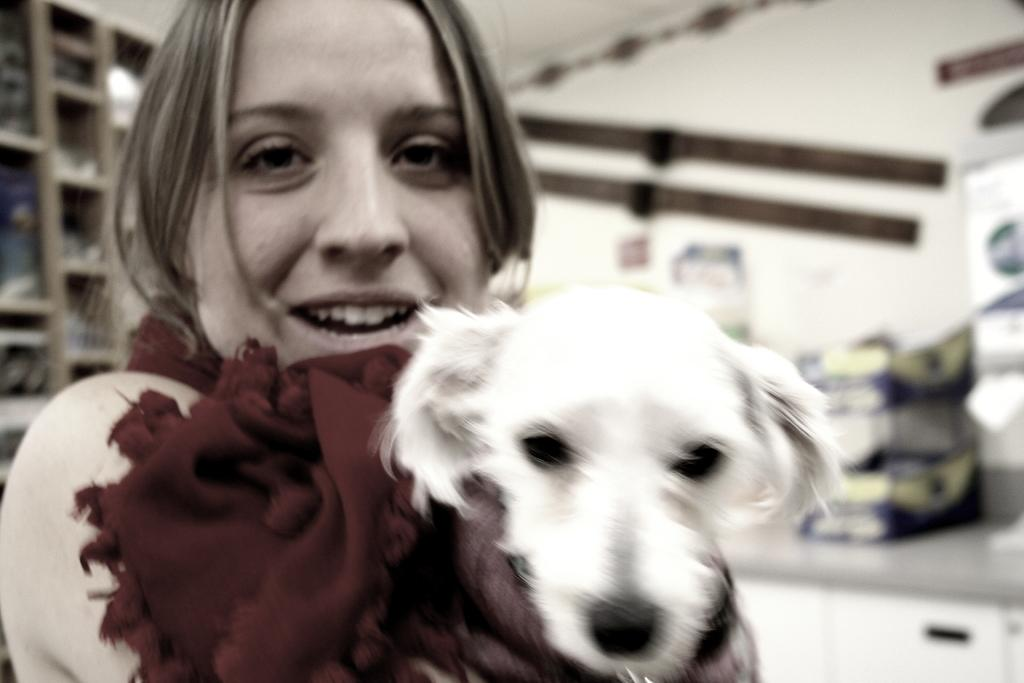Who is present in the image? There is a woman in the image. What is the woman doing in the image? The woman is smiling and holding a dog. What can be seen in the background of the image? There are racks and a wall in the background of the image. How would you describe the background of the image? The background is blurry. What type of pie is the woman holding in the image? There is no pie present in the image; the woman is holding a dog. 